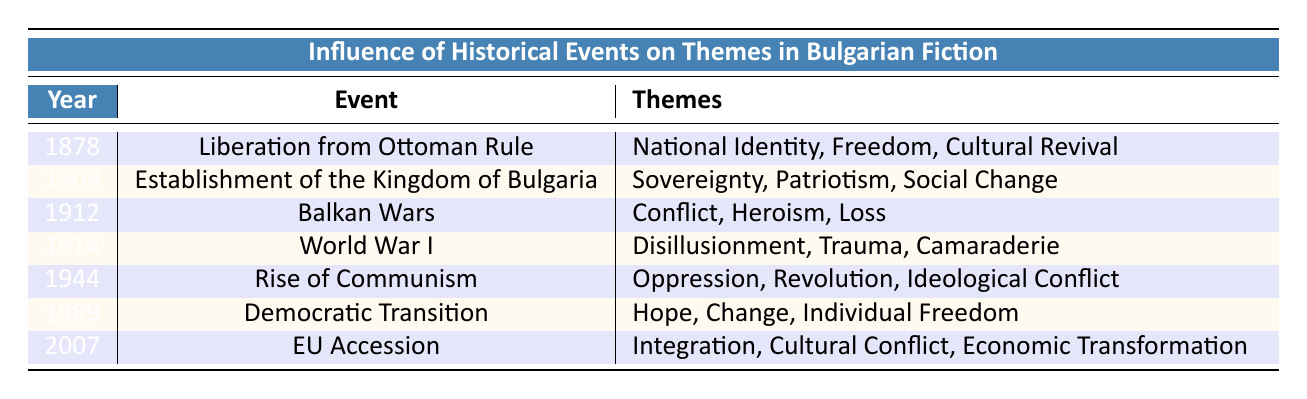What themes are associated with the Liberation from Ottoman Rule? The table lists the themes related to the Liberation from Ottoman Rule as "National Identity," "Freedom," and "Cultural Revival."
Answer: National Identity, Freedom, Cultural Revival What year did the establishment of the Kingdom of Bulgaria occur? The table specifies that the event of establishing the Kingdom of Bulgaria took place in the year 1908.
Answer: 1908 Which historical event is connected to the themes of Disillusionment and Trauma? By examining the themes in the table, World War I is the event related to "Disillusionment" and "Trauma."
Answer: World War I Is "Hope" a theme associated with the Rise of Communism? The table indicates that "Hope" is not listed as a theme for the Rise of Communism; it instead features "Oppression," "Revolution," and "Ideological Conflict."
Answer: No What themes appear in both World War I and the Democratic Transition? The themes of "Camaraderie" from World War I and "Hope" from the Democratic Transition do not overlap. However, both share a focus on values relevant to their respective social contexts.
Answer: No common themes Which event corresponds to the theme of "Integration"? The table indicates that the theme "Integration" is associated with the EU Accession event that took place in 2007.
Answer: EU Accession What significant change in themes occurs from the Balkan Wars to World War I? Comparing the themes, "Conflict," "Heroism," and "Loss" from the Balkan Wars transition to "Disillusionment," "Trauma," and "Camaraderie" in World War I, which reflects a more complex emotional response to the consequences of war.
Answer: Shift from conflict and heroism to disillusionment and trauma How many events listed before 1944 involve themes of conflict? The events listed before 1944 that involve themes of conflict are the Liberation from Ottoman Rule, Balkan Wars, and World War I. This totals to three events that directly address conflict.
Answer: 3 Does the theme "Cultural Revival" appear in the same row as "Economic Transformation"? "Cultural Revival" is linked to the Liberation from Ottoman Rule, while "Economic Transformation" is associated with EU Accession. Since these are different events, the answer is no.
Answer: No 